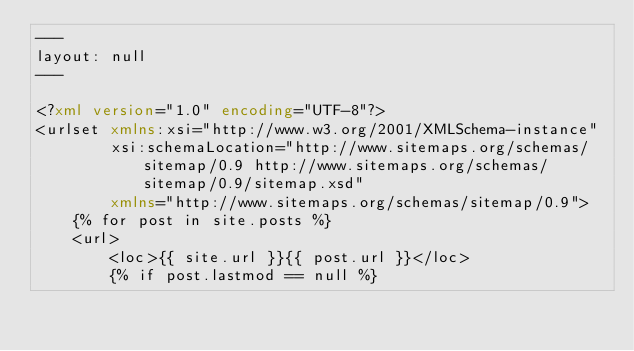Convert code to text. <code><loc_0><loc_0><loc_500><loc_500><_XML_>---
layout: null
---

<?xml version="1.0" encoding="UTF-8"?>
<urlset xmlns:xsi="http://www.w3.org/2001/XMLSchema-instance"
        xsi:schemaLocation="http://www.sitemaps.org/schemas/sitemap/0.9 http://www.sitemaps.org/schemas/sitemap/0.9/sitemap.xsd"
        xmlns="http://www.sitemaps.org/schemas/sitemap/0.9">
    {% for post in site.posts %}
    <url>
        <loc>{{ site.url }}{{ post.url }}</loc>
        {% if post.lastmod == null %}</code> 